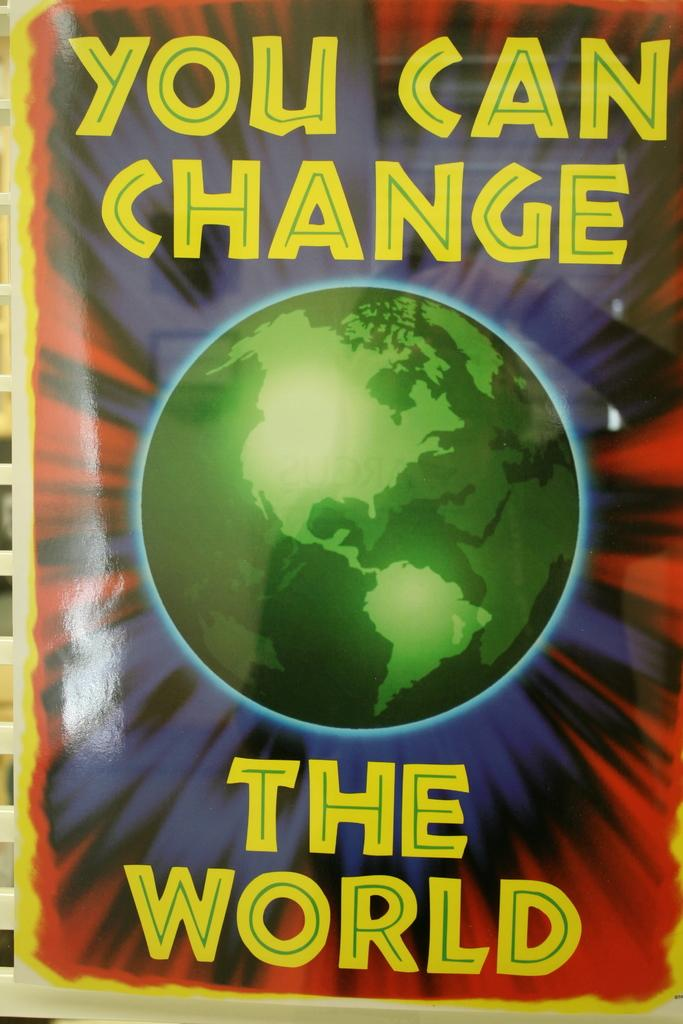<image>
Summarize the visual content of the image. A poster that says you can change the world 